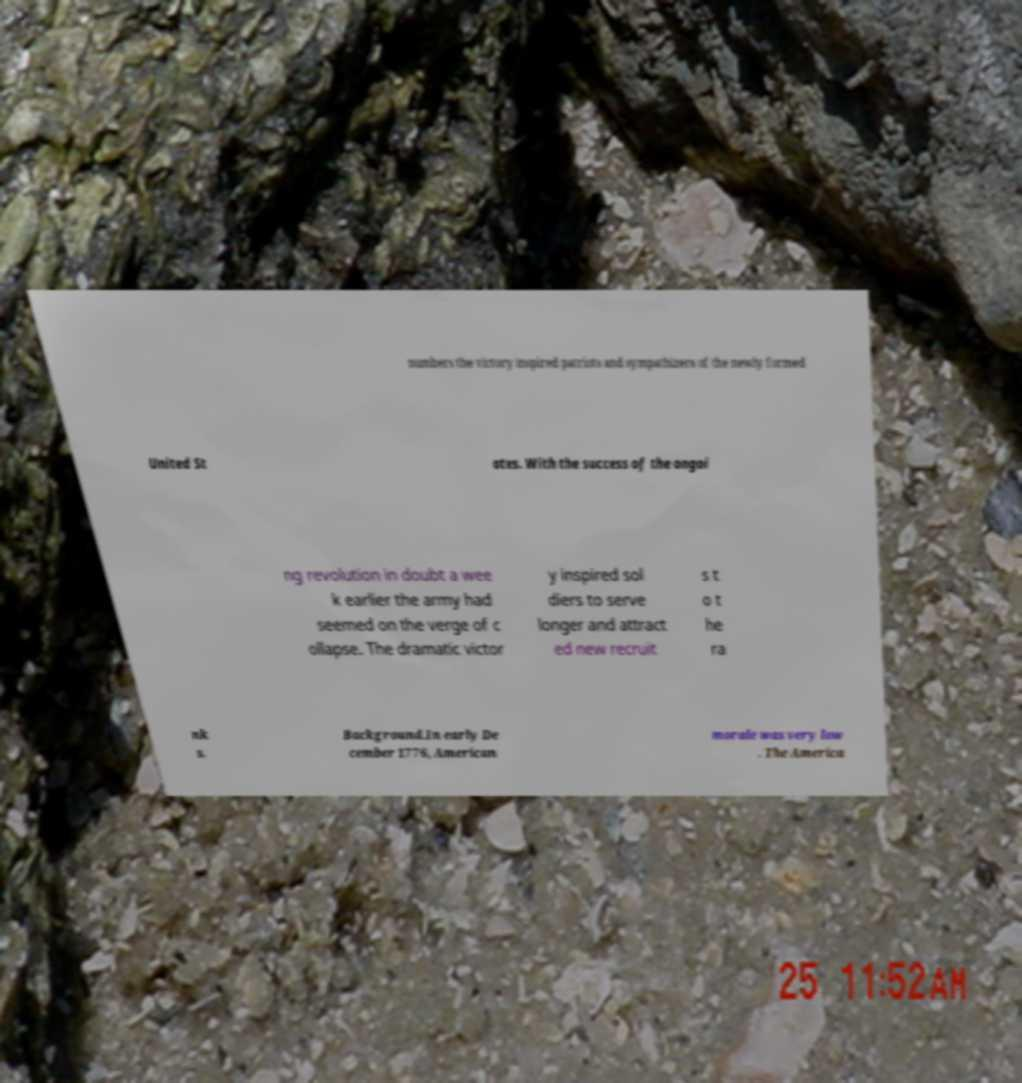For documentation purposes, I need the text within this image transcribed. Could you provide that? numbers the victory inspired patriots and sympathizers of the newly formed United St ates. With the success of the ongoi ng revolution in doubt a wee k earlier the army had seemed on the verge of c ollapse. The dramatic victor y inspired sol diers to serve longer and attract ed new recruit s t o t he ra nk s. Background.In early De cember 1776, American morale was very low . The America 